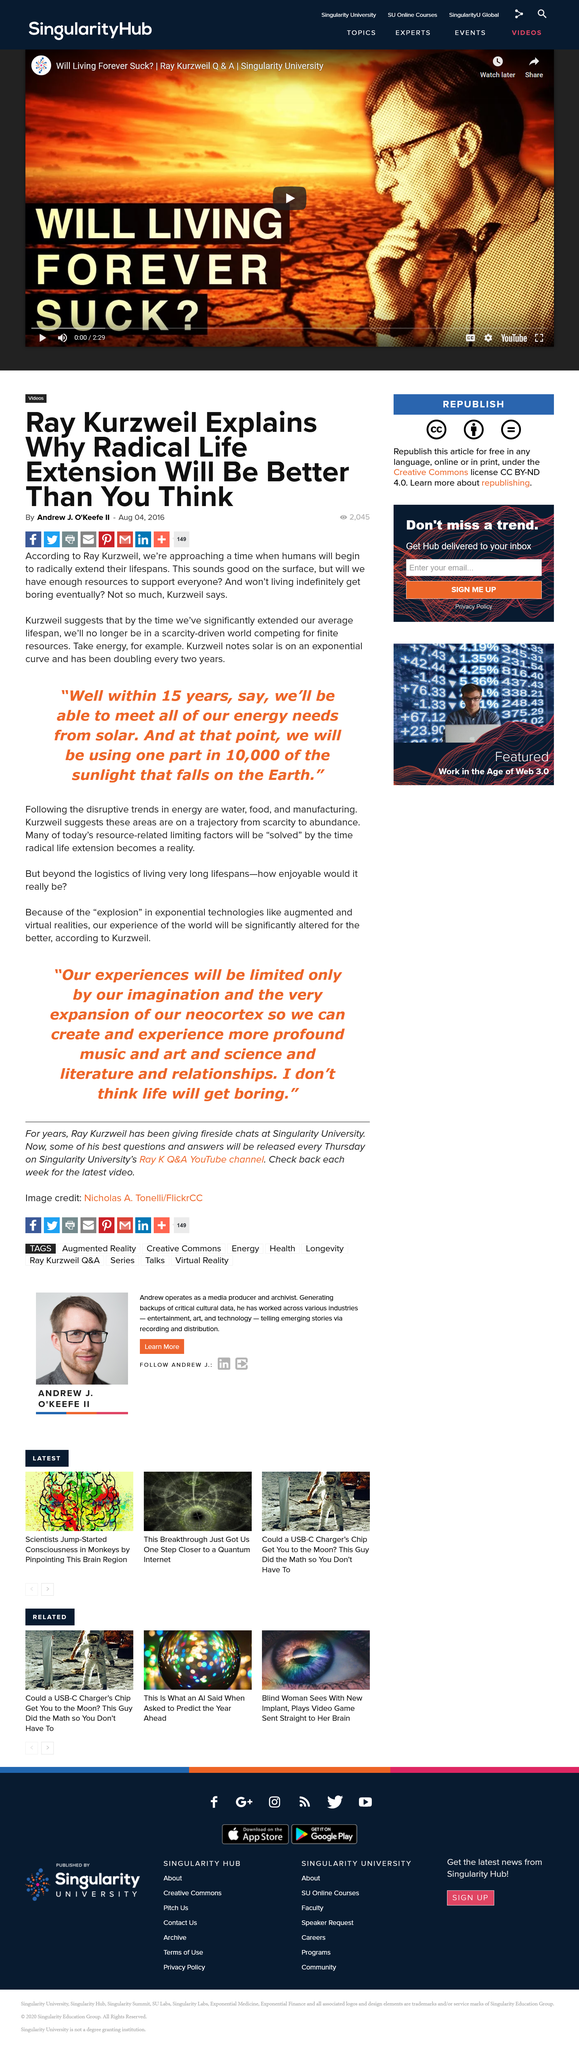Outline some significant characteristics in this image. Only a minuscule fraction of the sunlight will be utilized for solar power, at one part in 10,000. Within 15 years, according to Kurzweil, we will have met all of our energy needs from solar. Solar energy doubles every two years. 